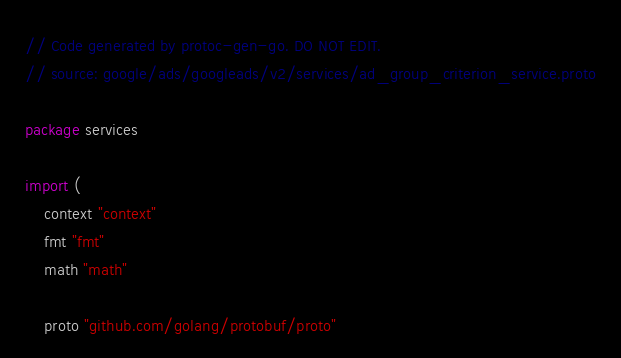<code> <loc_0><loc_0><loc_500><loc_500><_Go_>// Code generated by protoc-gen-go. DO NOT EDIT.
// source: google/ads/googleads/v2/services/ad_group_criterion_service.proto

package services

import (
	context "context"
	fmt "fmt"
	math "math"

	proto "github.com/golang/protobuf/proto"</code> 